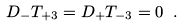Convert formula to latex. <formula><loc_0><loc_0><loc_500><loc_500>D _ { - } T _ { + 3 } = D _ { + } T _ { - 3 } = 0 \ .</formula> 